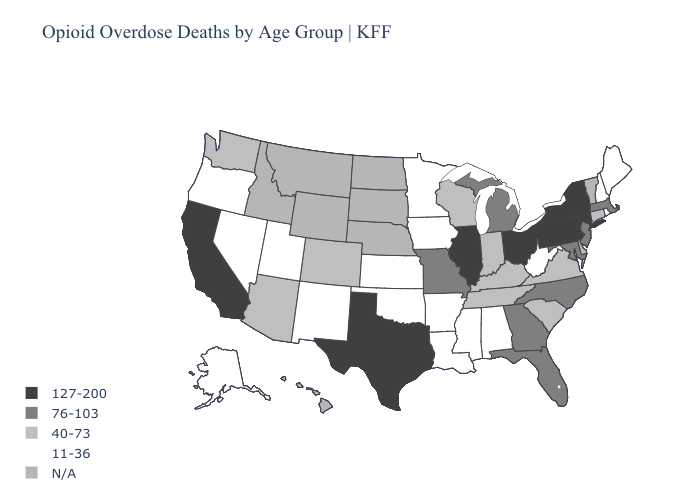Name the states that have a value in the range 127-200?
Be succinct. California, Illinois, New York, Ohio, Pennsylvania, Texas. Name the states that have a value in the range 127-200?
Be succinct. California, Illinois, New York, Ohio, Pennsylvania, Texas. What is the highest value in the South ?
Short answer required. 127-200. What is the value of New Mexico?
Be succinct. 11-36. Does Oklahoma have the highest value in the South?
Be succinct. No. Which states have the highest value in the USA?
Quick response, please. California, Illinois, New York, Ohio, Pennsylvania, Texas. What is the value of Iowa?
Concise answer only. 11-36. Does South Carolina have the lowest value in the South?
Write a very short answer. No. Which states hav the highest value in the MidWest?
Give a very brief answer. Illinois, Ohio. Does the map have missing data?
Answer briefly. Yes. Among the states that border Arizona , does California have the highest value?
Keep it brief. Yes. Among the states that border Ohio , does Kentucky have the highest value?
Write a very short answer. No. What is the value of New York?
Give a very brief answer. 127-200. Does North Carolina have the lowest value in the South?
Be succinct. No. Does Illinois have the highest value in the USA?
Be succinct. Yes. 